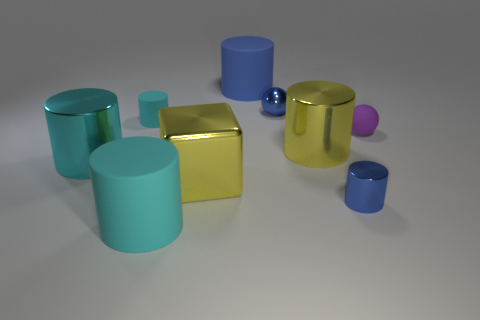Is the size of the yellow cylinder the same as the yellow cube?
Ensure brevity in your answer.  Yes. There is a large shiny object that is behind the large yellow cube and left of the large yellow metal cylinder; what is its color?
Ensure brevity in your answer.  Cyan. What shape is the yellow thing that is the same material as the yellow cylinder?
Your response must be concise. Cube. What number of cylinders are in front of the yellow shiny cube and right of the big yellow shiny cube?
Offer a very short reply. 1. Are there any tiny objects in front of the tiny matte sphere?
Keep it short and to the point. Yes. There is a small blue shiny object behind the small rubber ball; does it have the same shape as the small purple rubber thing right of the large yellow shiny cylinder?
Provide a succinct answer. Yes. How many objects are matte balls or yellow things that are on the left side of the big yellow metallic cylinder?
Make the answer very short. 2. What number of other things are the same shape as the large blue rubber object?
Provide a short and direct response. 5. Does the yellow cylinder on the left side of the tiny purple ball have the same material as the small blue cylinder?
Make the answer very short. Yes. How many things are large cylinders or small rubber spheres?
Offer a terse response. 5. 